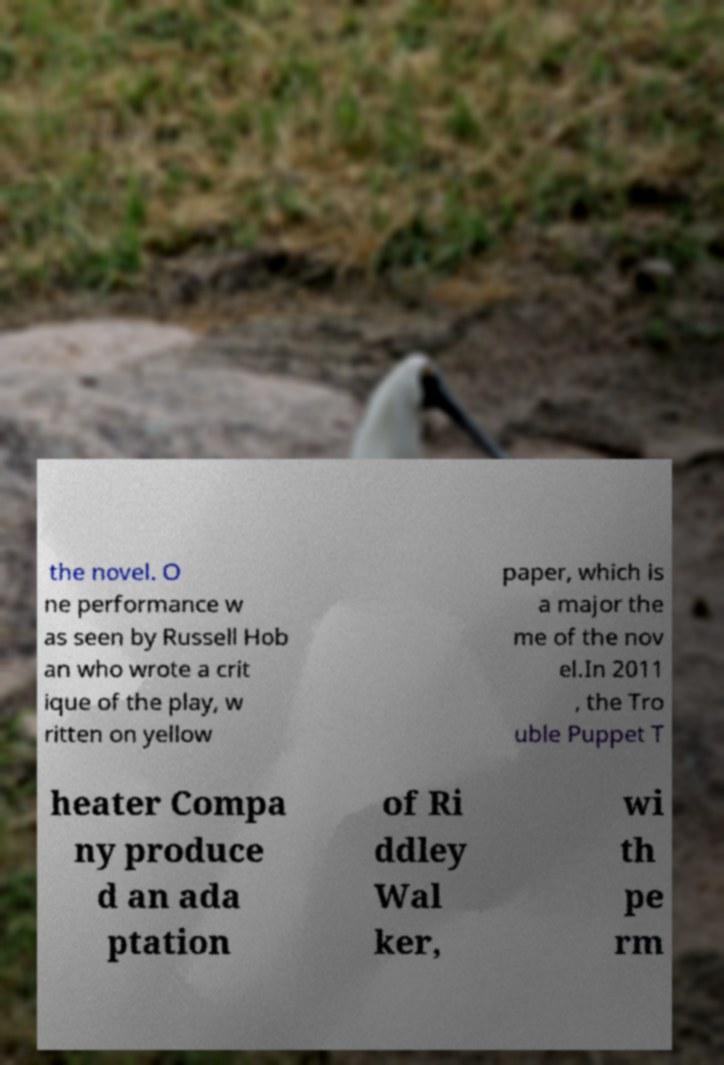I need the written content from this picture converted into text. Can you do that? the novel. O ne performance w as seen by Russell Hob an who wrote a crit ique of the play, w ritten on yellow paper, which is a major the me of the nov el.In 2011 , the Tro uble Puppet T heater Compa ny produce d an ada ptation of Ri ddley Wal ker, wi th pe rm 